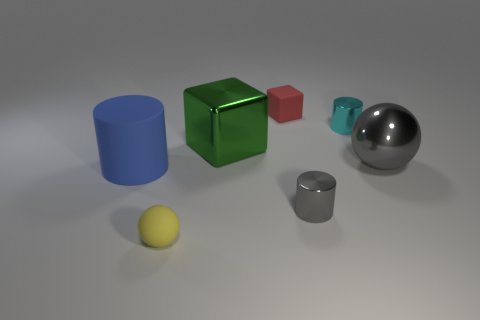Do the gray thing that is in front of the blue rubber thing and the large thing left of the matte sphere have the same shape?
Make the answer very short. Yes. What number of spheres are either tiny blue things or tiny red objects?
Your response must be concise. 0. Are there fewer small cyan cylinders in front of the cyan metal thing than cyan shiny things?
Provide a short and direct response. Yes. How many other things are there of the same material as the red block?
Offer a very short reply. 2. Do the green shiny cube and the yellow thing have the same size?
Keep it short and to the point. No. What number of objects are either large rubber cylinders that are left of the green thing or gray shiny things?
Provide a short and direct response. 3. What material is the object that is in front of the small metallic thing in front of the large sphere?
Ensure brevity in your answer.  Rubber. Is there a small red thing that has the same shape as the big green thing?
Keep it short and to the point. Yes. There is a cyan metallic cylinder; does it have the same size as the metallic cube that is behind the large gray thing?
Provide a short and direct response. No. What number of things are either matte objects to the left of the green metal block or tiny shiny objects that are in front of the tiny cyan metal cylinder?
Offer a very short reply. 3. 